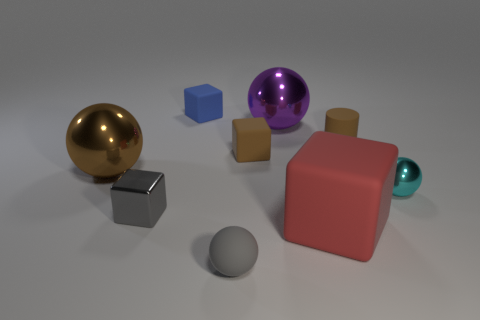Add 1 big matte objects. How many objects exist? 10 Subtract all blocks. How many objects are left? 5 Subtract 0 blue balls. How many objects are left? 9 Subtract all brown rubber cylinders. Subtract all brown metallic balls. How many objects are left? 7 Add 1 red things. How many red things are left? 2 Add 4 small red matte spheres. How many small red matte spheres exist? 4 